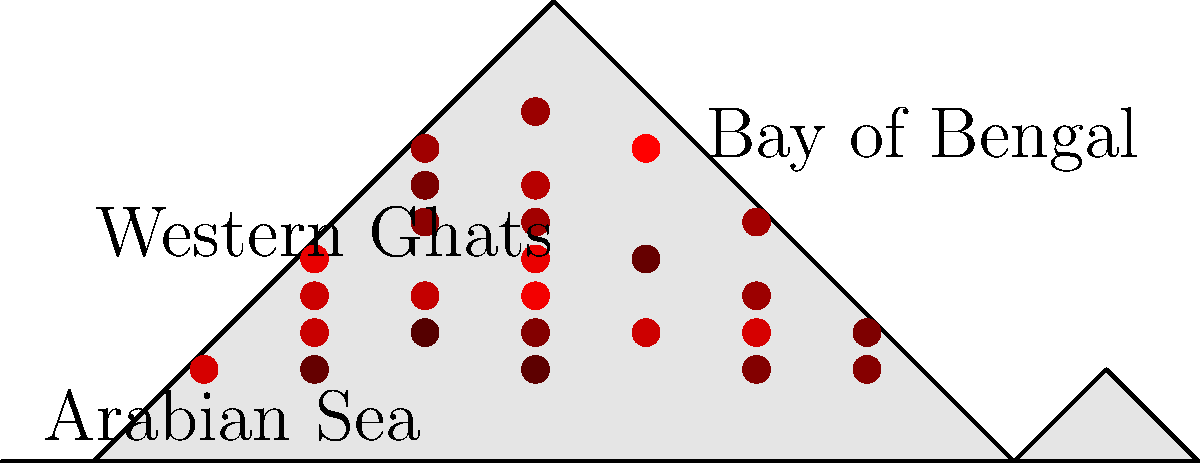Analyze the weather radar image showing monsoonal precipitation patterns across India. Which region appears to have the highest concentration of intense rainfall, and what geographical feature likely contributes to this pattern? To analyze this weather radar image and identify the region with the highest concentration of intense rainfall, we need to follow these steps:

1. Observe the distribution of red dots across the map of India. The red dots represent areas of precipitation, with darker red indicating more intense rainfall.

2. Notice that there is a higher concentration of dark red dots along the western coast of India.

3. Identify the geographical features labeled on the map. We can see "Western Ghats" labeled along the western coast.

4. Recall that the Western Ghats are a mountain range running parallel to India's western coast.

5. Understand the orographic effect: When moisture-laden monsoon winds from the Arabian Sea encounter the Western Ghats, they are forced to rise. As the air rises, it cools and condenses, leading to heavy rainfall on the windward side of the mountains.

6. Observe that the concentration of intense rainfall (dark red dots) aligns with the location of the Western Ghats.

Therefore, the region with the highest concentration of intense rainfall appears to be along the Western Ghats. The geographical feature contributing to this pattern is the Western Ghats mountain range, which causes orographic lifting of the monsoon winds, resulting in enhanced precipitation.
Answer: Western Ghats; orographic effect 